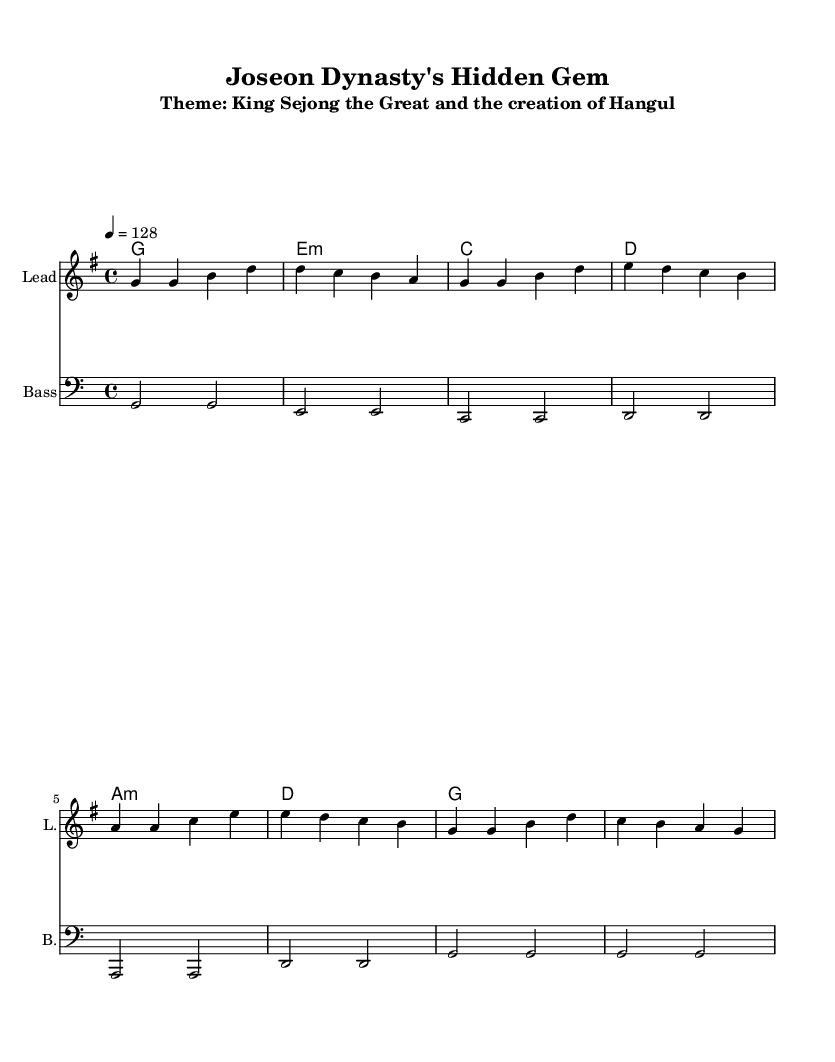What is the key signature of this music? The key signature is G major, indicated by an F# in the key signature box at the beginning of the staff.
Answer: G major What is the time signature of this piece? The time signature is 4/4, as shown with the numbers "4" over "4" located near the start of the piece.
Answer: 4/4 What is the tempo marking in this sheet music? The tempo marking is indicated by "4 = 128", meaning the quarter note is to be played at a speed of 128 beats per minute.
Answer: 128 How many measures are there in the melody? By counting the grouped notes in the melody section, there are 8 measures, each separated by a vertical line.
Answer: 8 measures What is the title of this piece? The title is shown at the top of the sheet music, which is "Joseon Dynasty's Hidden Gem." This provides a key context about the piece's inspiration.
Answer: Joseon Dynasty's Hidden Gem Which historical figure is featured in this piece? The subtitle mentions "King Sejong the Great" as the historical figure, indicating that the music is themed around his contributions, particularly regarding the creation of Hangul.
Answer: King Sejong the Great 